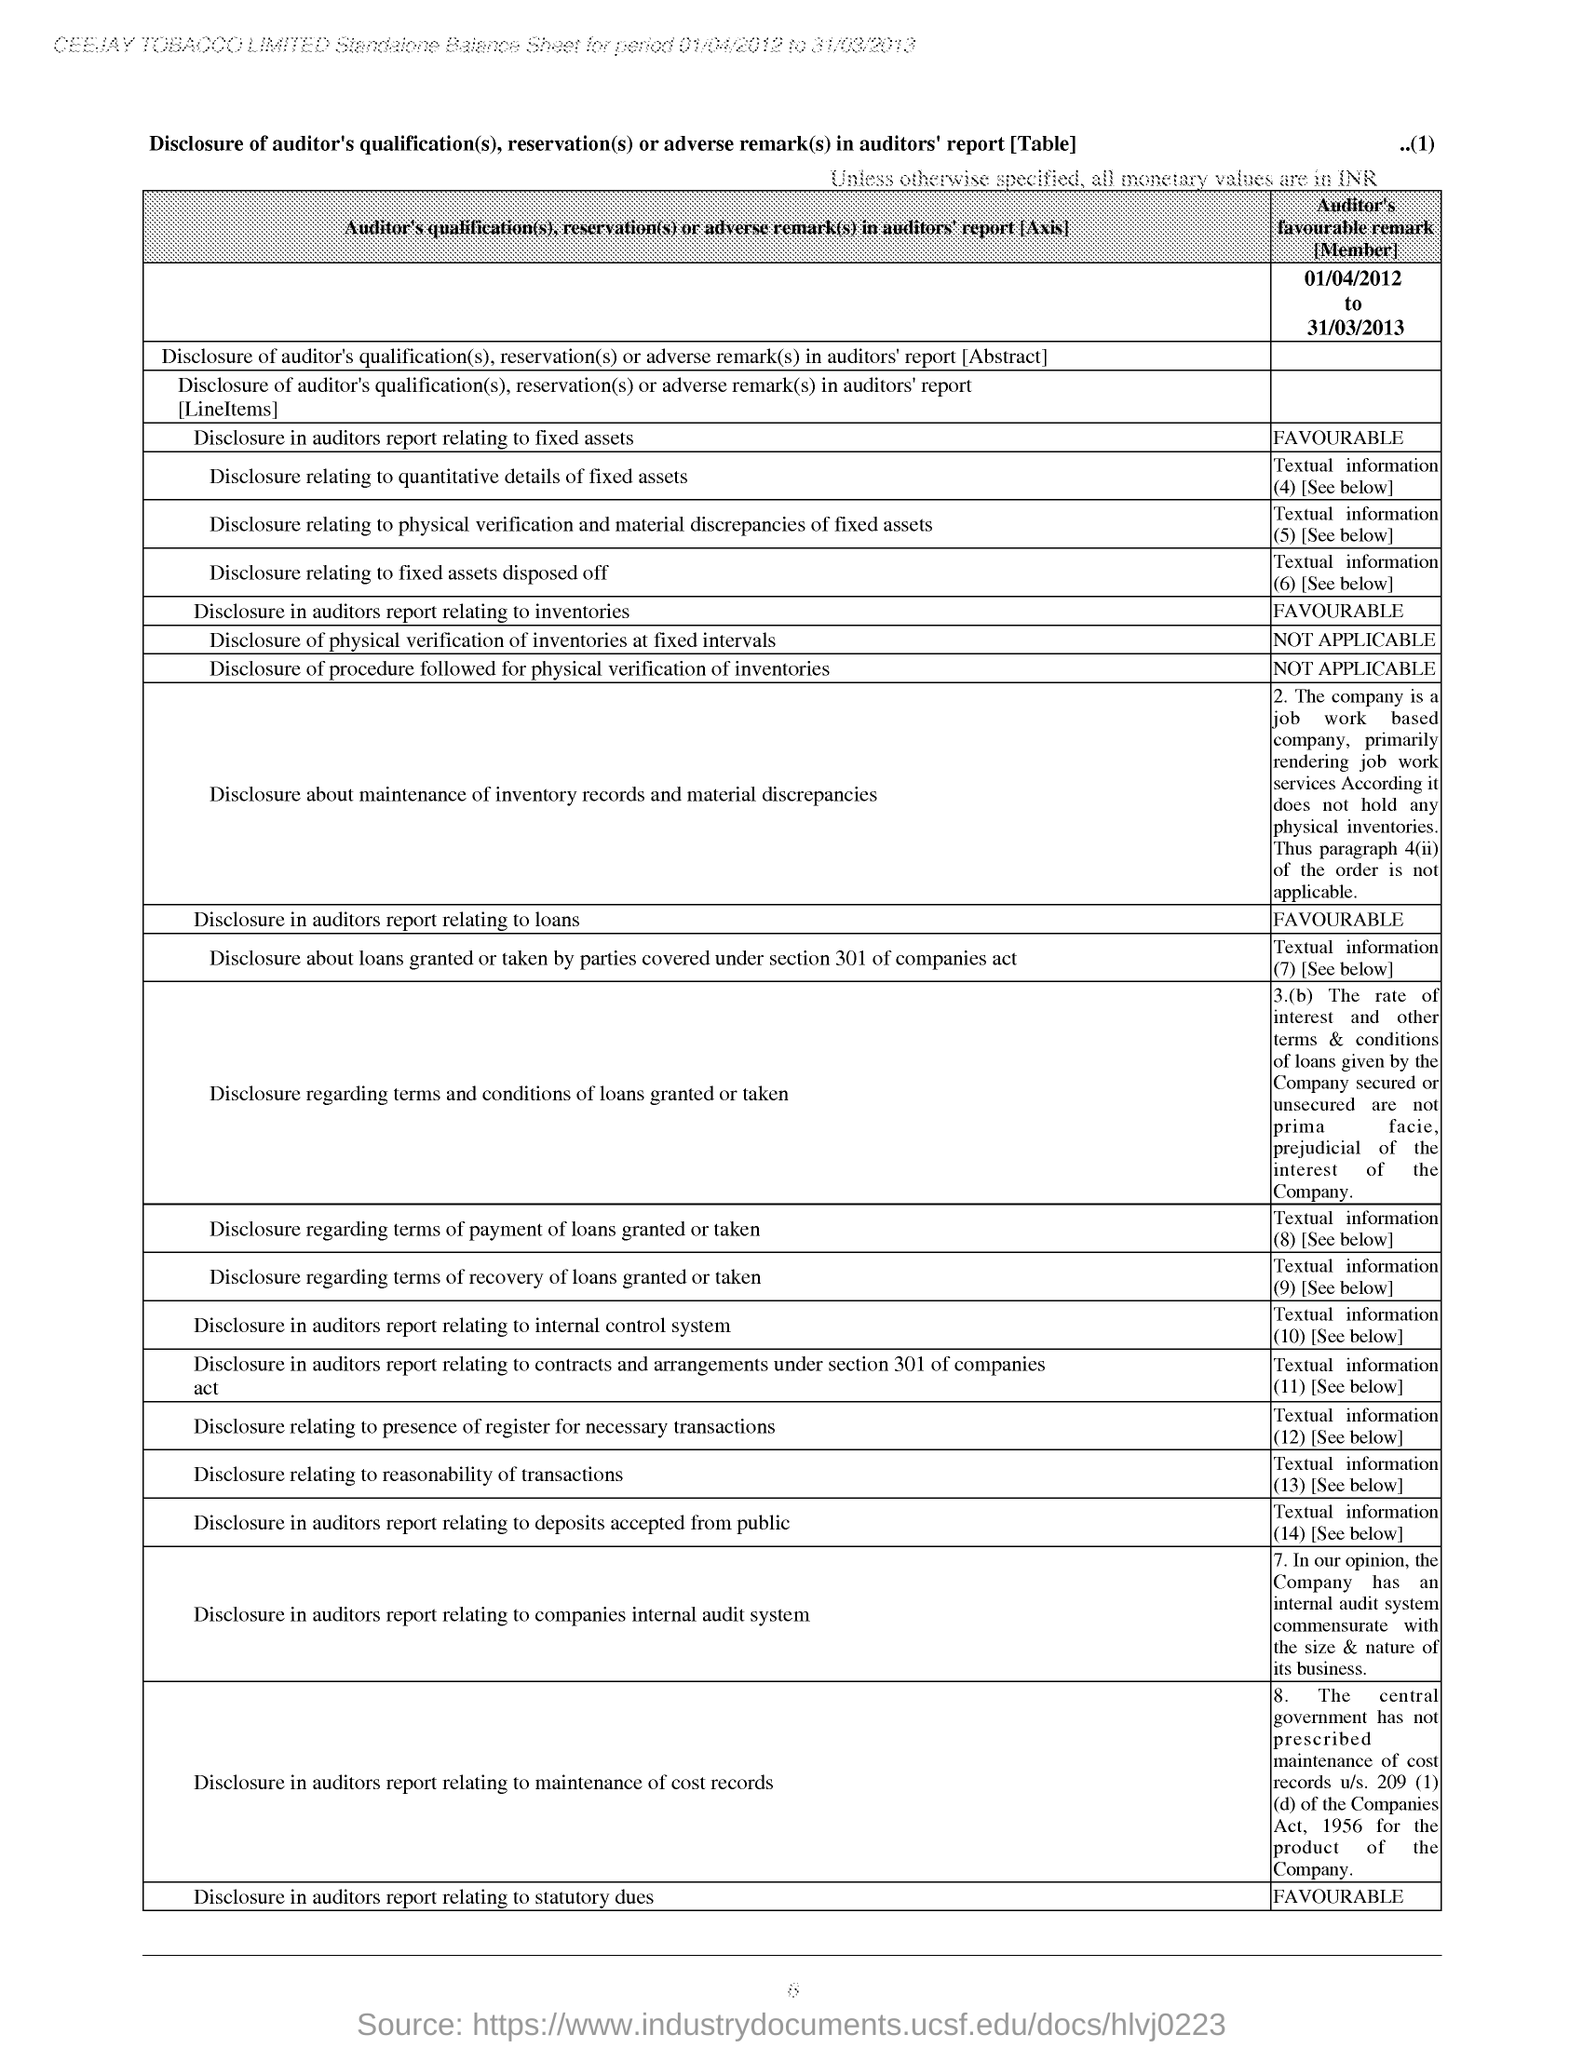What is the company name mentioned at the top of the page?
Offer a terse response. CEEJAY TOBACCO LIMITED. For which period duration is standalone Balance sheet made?
Ensure brevity in your answer.  Period 01/04/2012 to 31/03/2013. What is the Page number given at the top right corner of the page?
Make the answer very short. ..(1). How is the Auditor's remark for "Disclosure in auditors report relating to fixed assets"?
Provide a short and direct response. FAVOURABLE. How is the Auditor's remark for "Disclosure in auditors report relating to loans"?
Ensure brevity in your answer.  FAVOURABLE. How is the Auditor's remark for "Disclosure in auditors report relating to statutory dues"?
Provide a short and direct response. FAVOURABLE. What is the last Disclosure in the balance sheet?
Make the answer very short. Disclosure in auditors report relating to statutory dues. 